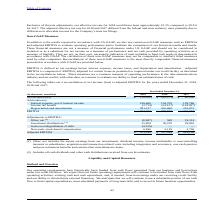According to Consolidated Communications Holdings's financial document, Which non-GAAP measures are used? EBITDA and adjusted EBITDA. The document states: "AP, we also use certain non-GAAP measures such as EBITDA and adjusted EBITDA to evaluate operating performance and to facilitate the comparison of our..." Also, What is the purpose of using EBITDA and adjusted EBITDA? to evaluate operating performance and to facilitate the comparison of our historical results and trends.. The document states: "n-GAAP measures such as EBITDA and adjusted EBITDA to evaluate operating performance and to facilitate the comparison of our historical results and tr..." Also, Which Industry commonly uses EBITDA and adjusted EBITDA for measuring operating performance? telecommunications industry. The document states: "a common measure of operating performance in the telecommunications industry and are useful, with other data, as a means to evaluate our ability to fu..." Also, can you calculate: What is the increase/ (decrease) in Net income (loss) from 2018 to 2019? Based on the calculation: -19,931-(-50,571), the result is 30640 (in thousands). This is based on the information: "Net income (loss) $ (19,931) $ (50,571) $ 65,299 Net income (loss) $ (19,931) $ (50,571) $ 65,299..." The key data points involved are: 19,931, 50,571. Also, can you calculate: What is the increase/ (decrease) in Interest expense, net of interest income from 2018 to 2019? Based on the calculation: 136,660-134,578, the result is 2082 (in thousands). This is based on the information: "Interest expense, net of interest income 136,660 134,578 129,786 Interest expense, net of interest income 136,660 134,578 129,786..." The key data points involved are: 134,578, 136,660. Also, can you calculate: What is the increase/ (decrease) in Income tax expense (benefit) from 2018 to 2019? Based on the calculation: -3,714-(-24,127), the result is 20413 (in thousands). This is based on the information: "Income tax benefit (3,714) (24,127) (124,927) Income tax benefit (3,714) (24,127) (124,927)..." The key data points involved are: 24,127, 3,714. 